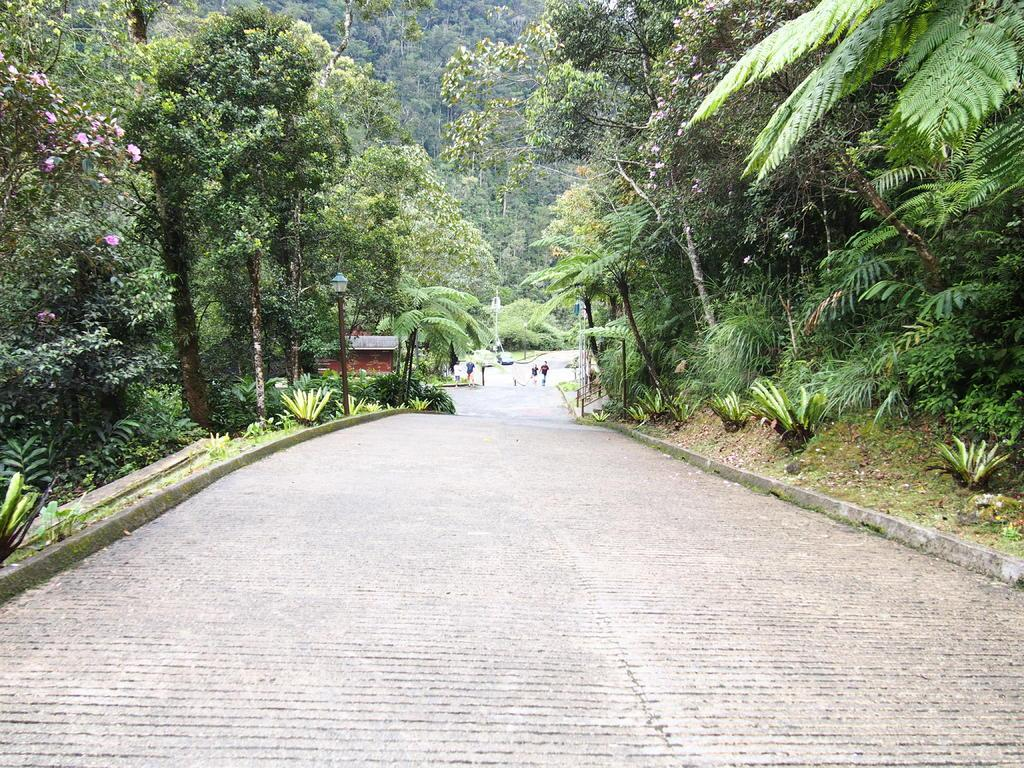What is the main feature of the image? There is a road in the image. Are there any living beings in the image? Yes, there are people in the image. What type of infrastructure is present in the image? Street lights are visible in the image. What type of natural elements can be seen in the image? There are trees in the image. Can you tell me how many hospitals are visible in the image? There are no hospitals present in the image. What type of breath can be seen coming from the trees in the image? Trees do not have the ability to breathe, so there is no breath visible in the image. 